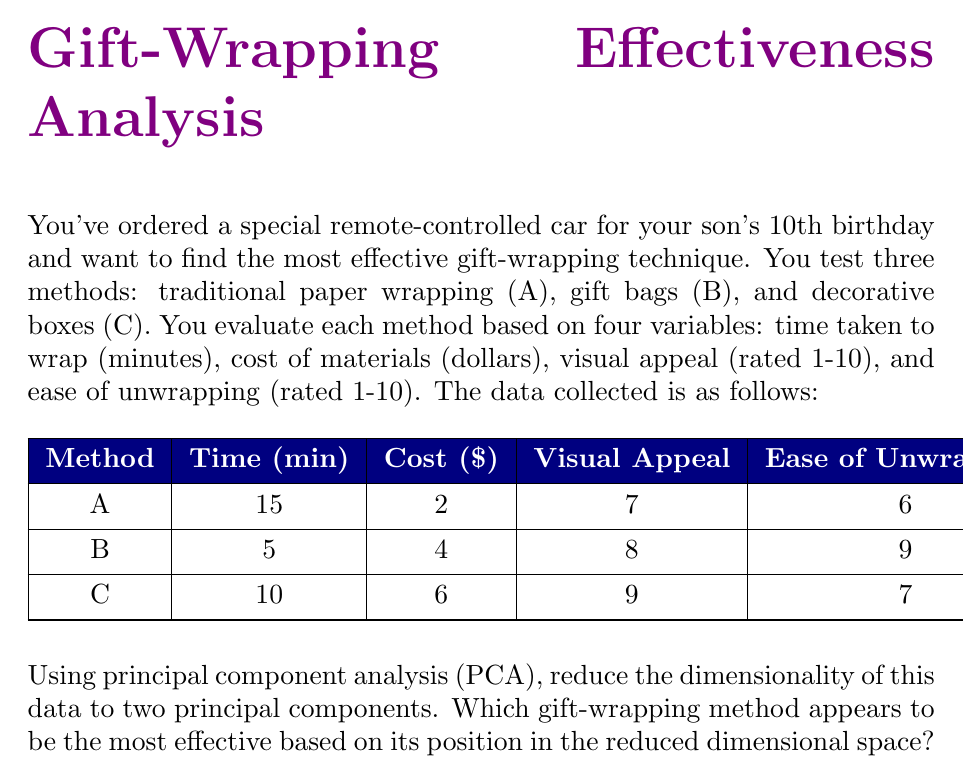Solve this math problem. To solve this problem using PCA, we'll follow these steps:

1) First, standardize the data to have zero mean and unit variance for each variable.

2) Compute the correlation matrix.

3) Calculate the eigenvalues and eigenvectors of the correlation matrix.

4) Select the top two principal components (PCs) based on the largest eigenvalues.

5) Project the data onto these two PCs and interpret the results.

Step 1: Standardize the data

Mean values:
$$\bar{x}_\text{Time} = 10, \bar{x}_\text{Cost} = 4, \bar{x}_\text{Visual} = 8, \bar{x}_\text{Ease} = 7.33$$

Standard deviations:
$$s_\text{Time} = 5, s_\text{Cost} = 2, s_\text{Visual} = 1, s_\text{Ease} = 1.53$$

Standardized data:
$$
\begin{array}{|c|c|c|c|c|}
\hline
\text{Method} & \text{Time} & \text{Cost} & \text{Visual} & \text{Ease} \\
\hline
A & 1 & -1 & -1 & -0.87 \\
B & -1 & 0 & 0 & 1.09 \\
C & 0 & 1 & 1 & -0.22 \\
\hline
\end{array}
$$

Step 2: Compute the correlation matrix

$$
R = \begin{bmatrix}
1 & 0 & 0 & -0.97 \\
0 & 1 & 1 & -0.22 \\
0 & 1 & 1 & -0.22 \\
-0.97 & -0.22 & -0.22 & 1
\end{bmatrix}
$$

Step 3: Calculate eigenvalues and eigenvectors

Eigenvalues: $\lambda_1 = 2.19, \lambda_2 = 1.81, \lambda_3 = 0, \lambda_4 = 0$

Corresponding eigenvectors:
$$
v_1 = [-0.52, -0.46, -0.46, 0.55]^T
$$
$$
v_2 = [0.47, -0.53, -0.53, -0.46]^T
$$

Step 4: Select top two PCs

We'll use the eigenvectors corresponding to $\lambda_1$ and $\lambda_2$.

Step 5: Project data onto PCs

PC1 scores:
$$
\text{A}: -0.52(1) - 0.46(-1) - 0.46(-1) + 0.55(-0.87) = 0.39
$$
$$
\text{B}: -0.52(-1) - 0.46(0) - 0.46(0) + 0.55(1.09) = 1.12
$$
$$
\text{C}: -0.52(0) - 0.46(1) - 0.46(1) + 0.55(-0.22) = -1.51
$$

PC2 scores:
$$
\text{A}: 0.47(1) - 0.53(-1) - 0.53(-1) - 0.46(-0.87) = 2.01
$$
$$
\text{B}: 0.47(-1) - 0.53(0) - 0.53(0) - 0.46(1.09) = -0.97
$$
$$
\text{C}: 0.47(0) - 0.53(1) - 0.53(1) - 0.46(-0.22) = -1.04
$$

Plotting these points in the PC1-PC2 space, we see that Method B (gift bags) has the highest PC1 score and a moderate PC2 score, suggesting it balances the variables well and appears to be the most effective overall.
Answer: Method B (gift bags) 